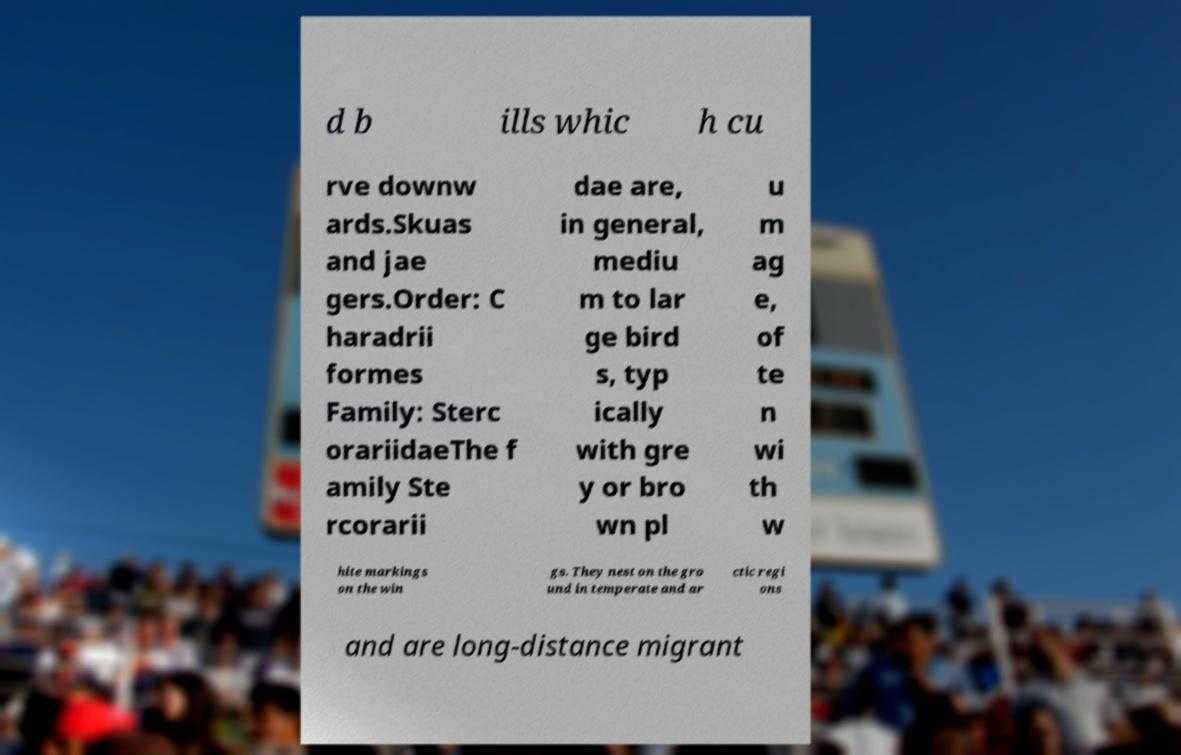Could you assist in decoding the text presented in this image and type it out clearly? d b ills whic h cu rve downw ards.Skuas and jae gers.Order: C haradrii formes Family: Sterc orariidaeThe f amily Ste rcorarii dae are, in general, mediu m to lar ge bird s, typ ically with gre y or bro wn pl u m ag e, of te n wi th w hite markings on the win gs. They nest on the gro und in temperate and ar ctic regi ons and are long-distance migrant 